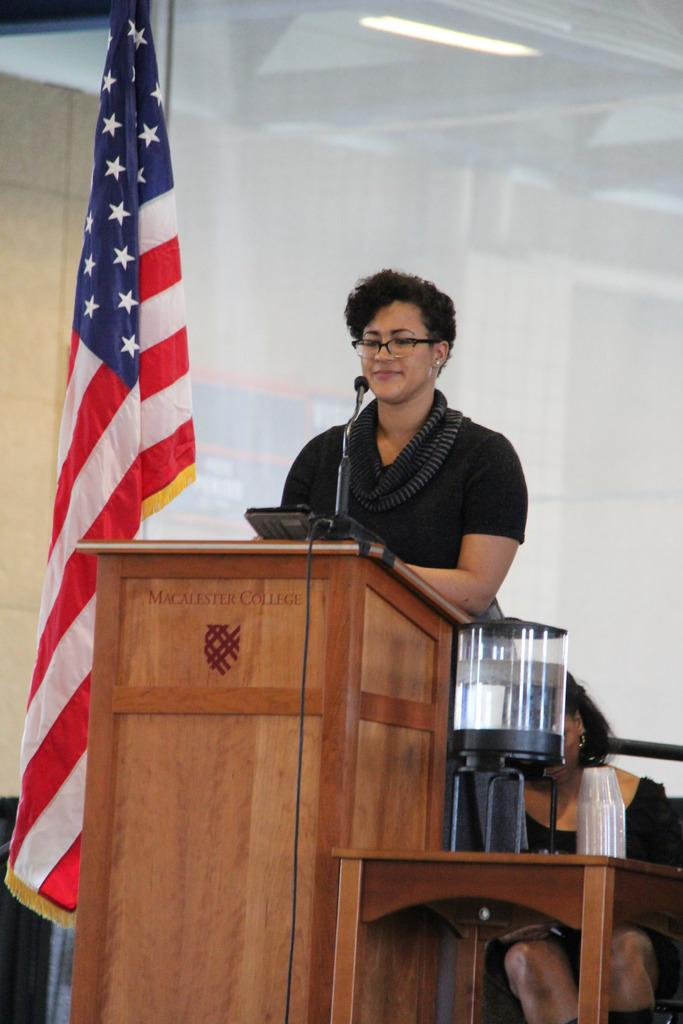Provide a one-sentence caption for the provided image. a woman at a podium in front of a stars and stripes flag with Macallester. 